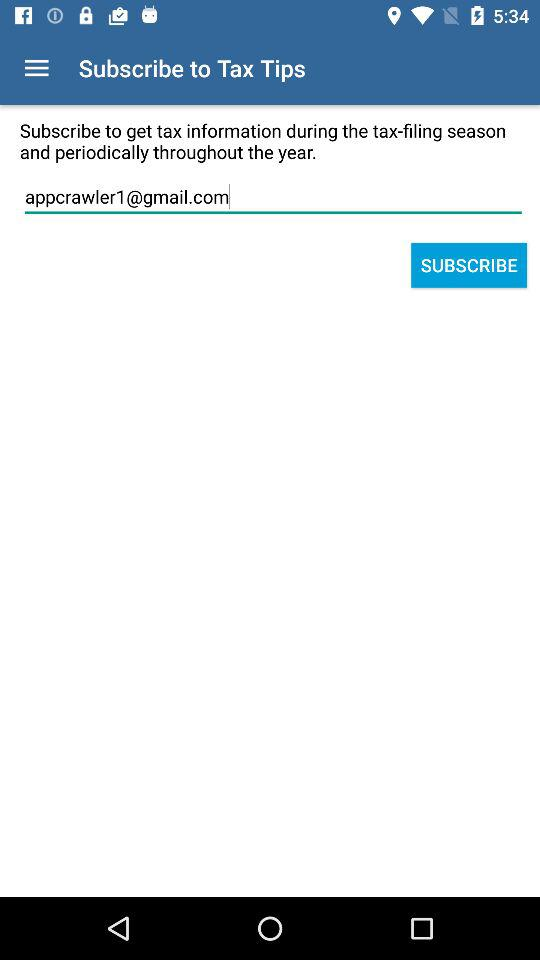What's the Google Mail address used by the user to subscribe? The Google Mail address is appcrawler1@gmail.com. 